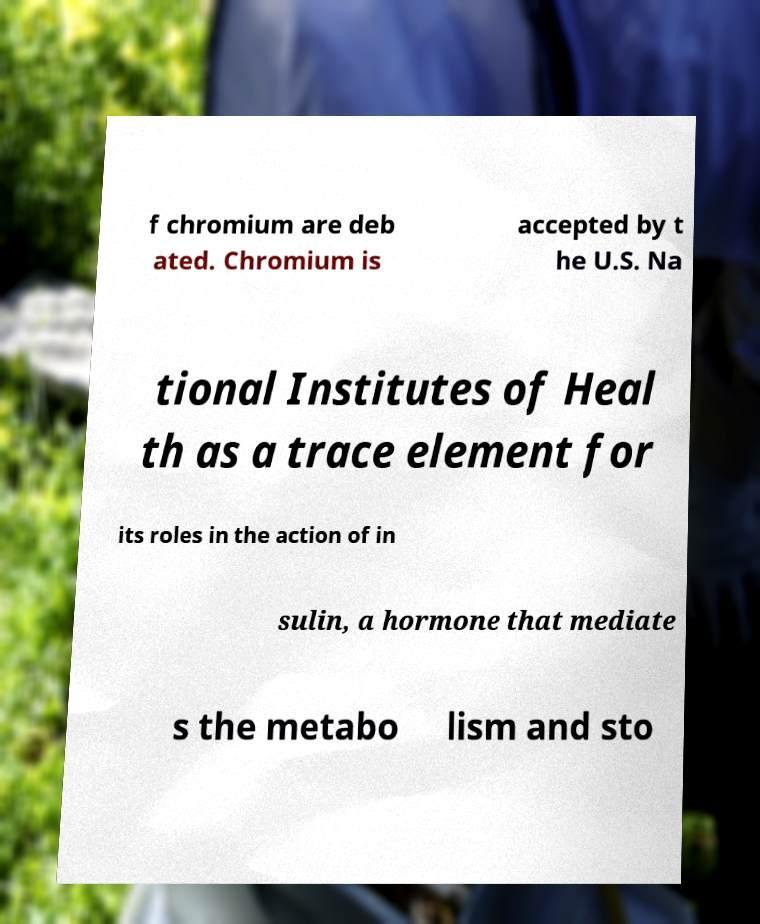Can you read and provide the text displayed in the image?This photo seems to have some interesting text. Can you extract and type it out for me? f chromium are deb ated. Chromium is accepted by t he U.S. Na tional Institutes of Heal th as a trace element for its roles in the action of in sulin, a hormone that mediate s the metabo lism and sto 